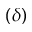Convert formula to latex. <formula><loc_0><loc_0><loc_500><loc_500>( \delta )</formula> 